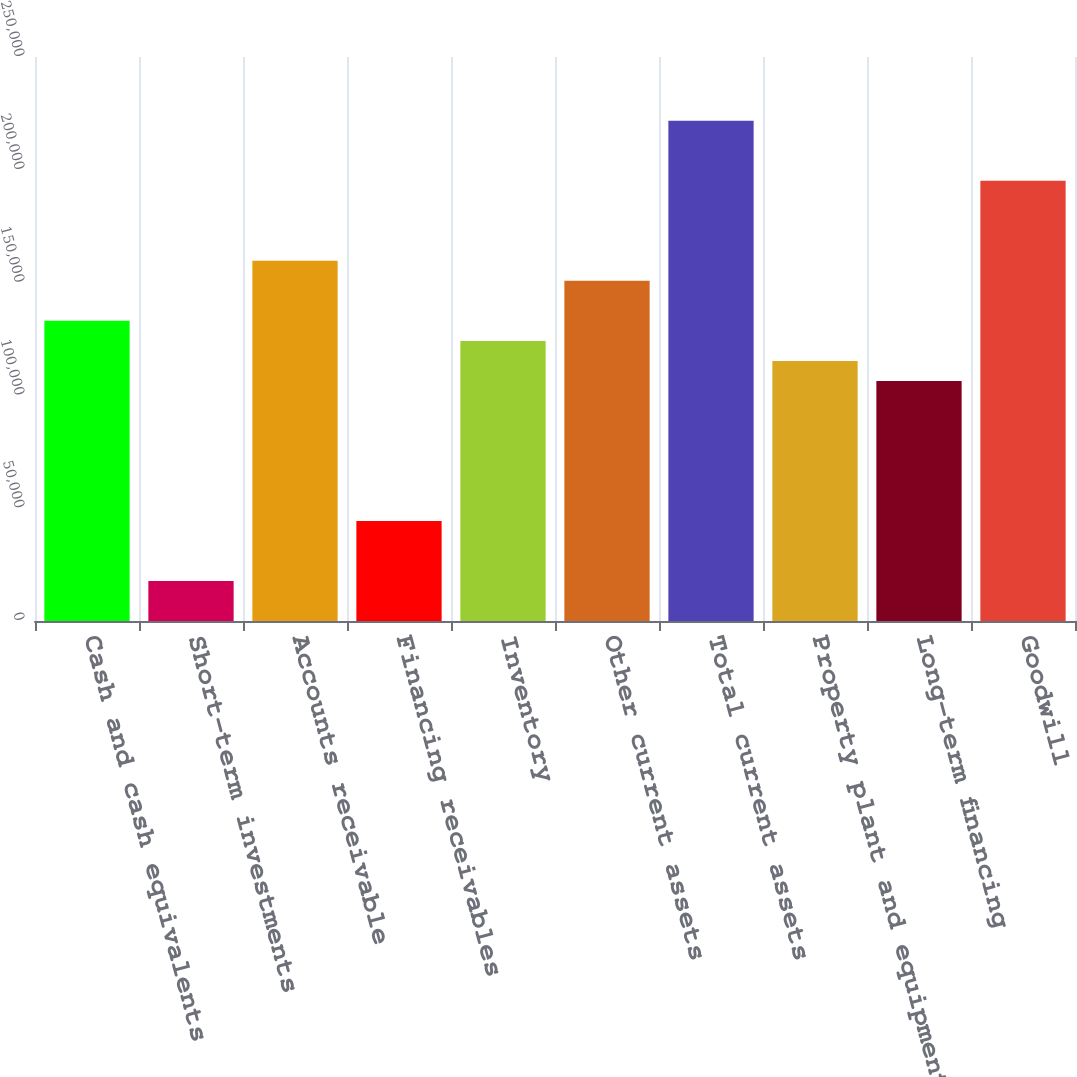Convert chart to OTSL. <chart><loc_0><loc_0><loc_500><loc_500><bar_chart><fcel>Cash and cash equivalents<fcel>Short-term investments<fcel>Accounts receivable<fcel>Financing receivables<fcel>Inventory<fcel>Other current assets<fcel>Total current assets<fcel>Property plant and equipment<fcel>Long-term financing<fcel>Goodwill<nl><fcel>133036<fcel>17760.6<fcel>159637<fcel>44362.5<fcel>124168<fcel>150770<fcel>221708<fcel>115301<fcel>106434<fcel>195107<nl></chart> 